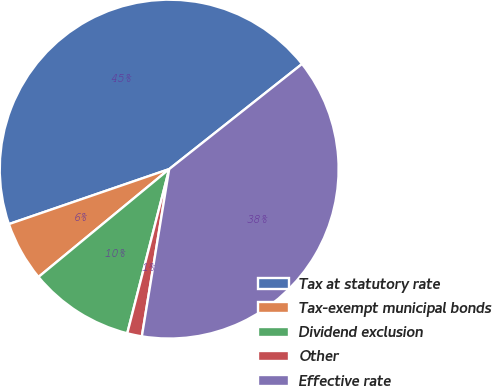Convert chart. <chart><loc_0><loc_0><loc_500><loc_500><pie_chart><fcel>Tax at statutory rate<fcel>Tax-exempt municipal bonds<fcel>Dividend exclusion<fcel>Other<fcel>Effective rate<nl><fcel>44.6%<fcel>5.72%<fcel>10.04%<fcel>1.4%<fcel>38.23%<nl></chart> 